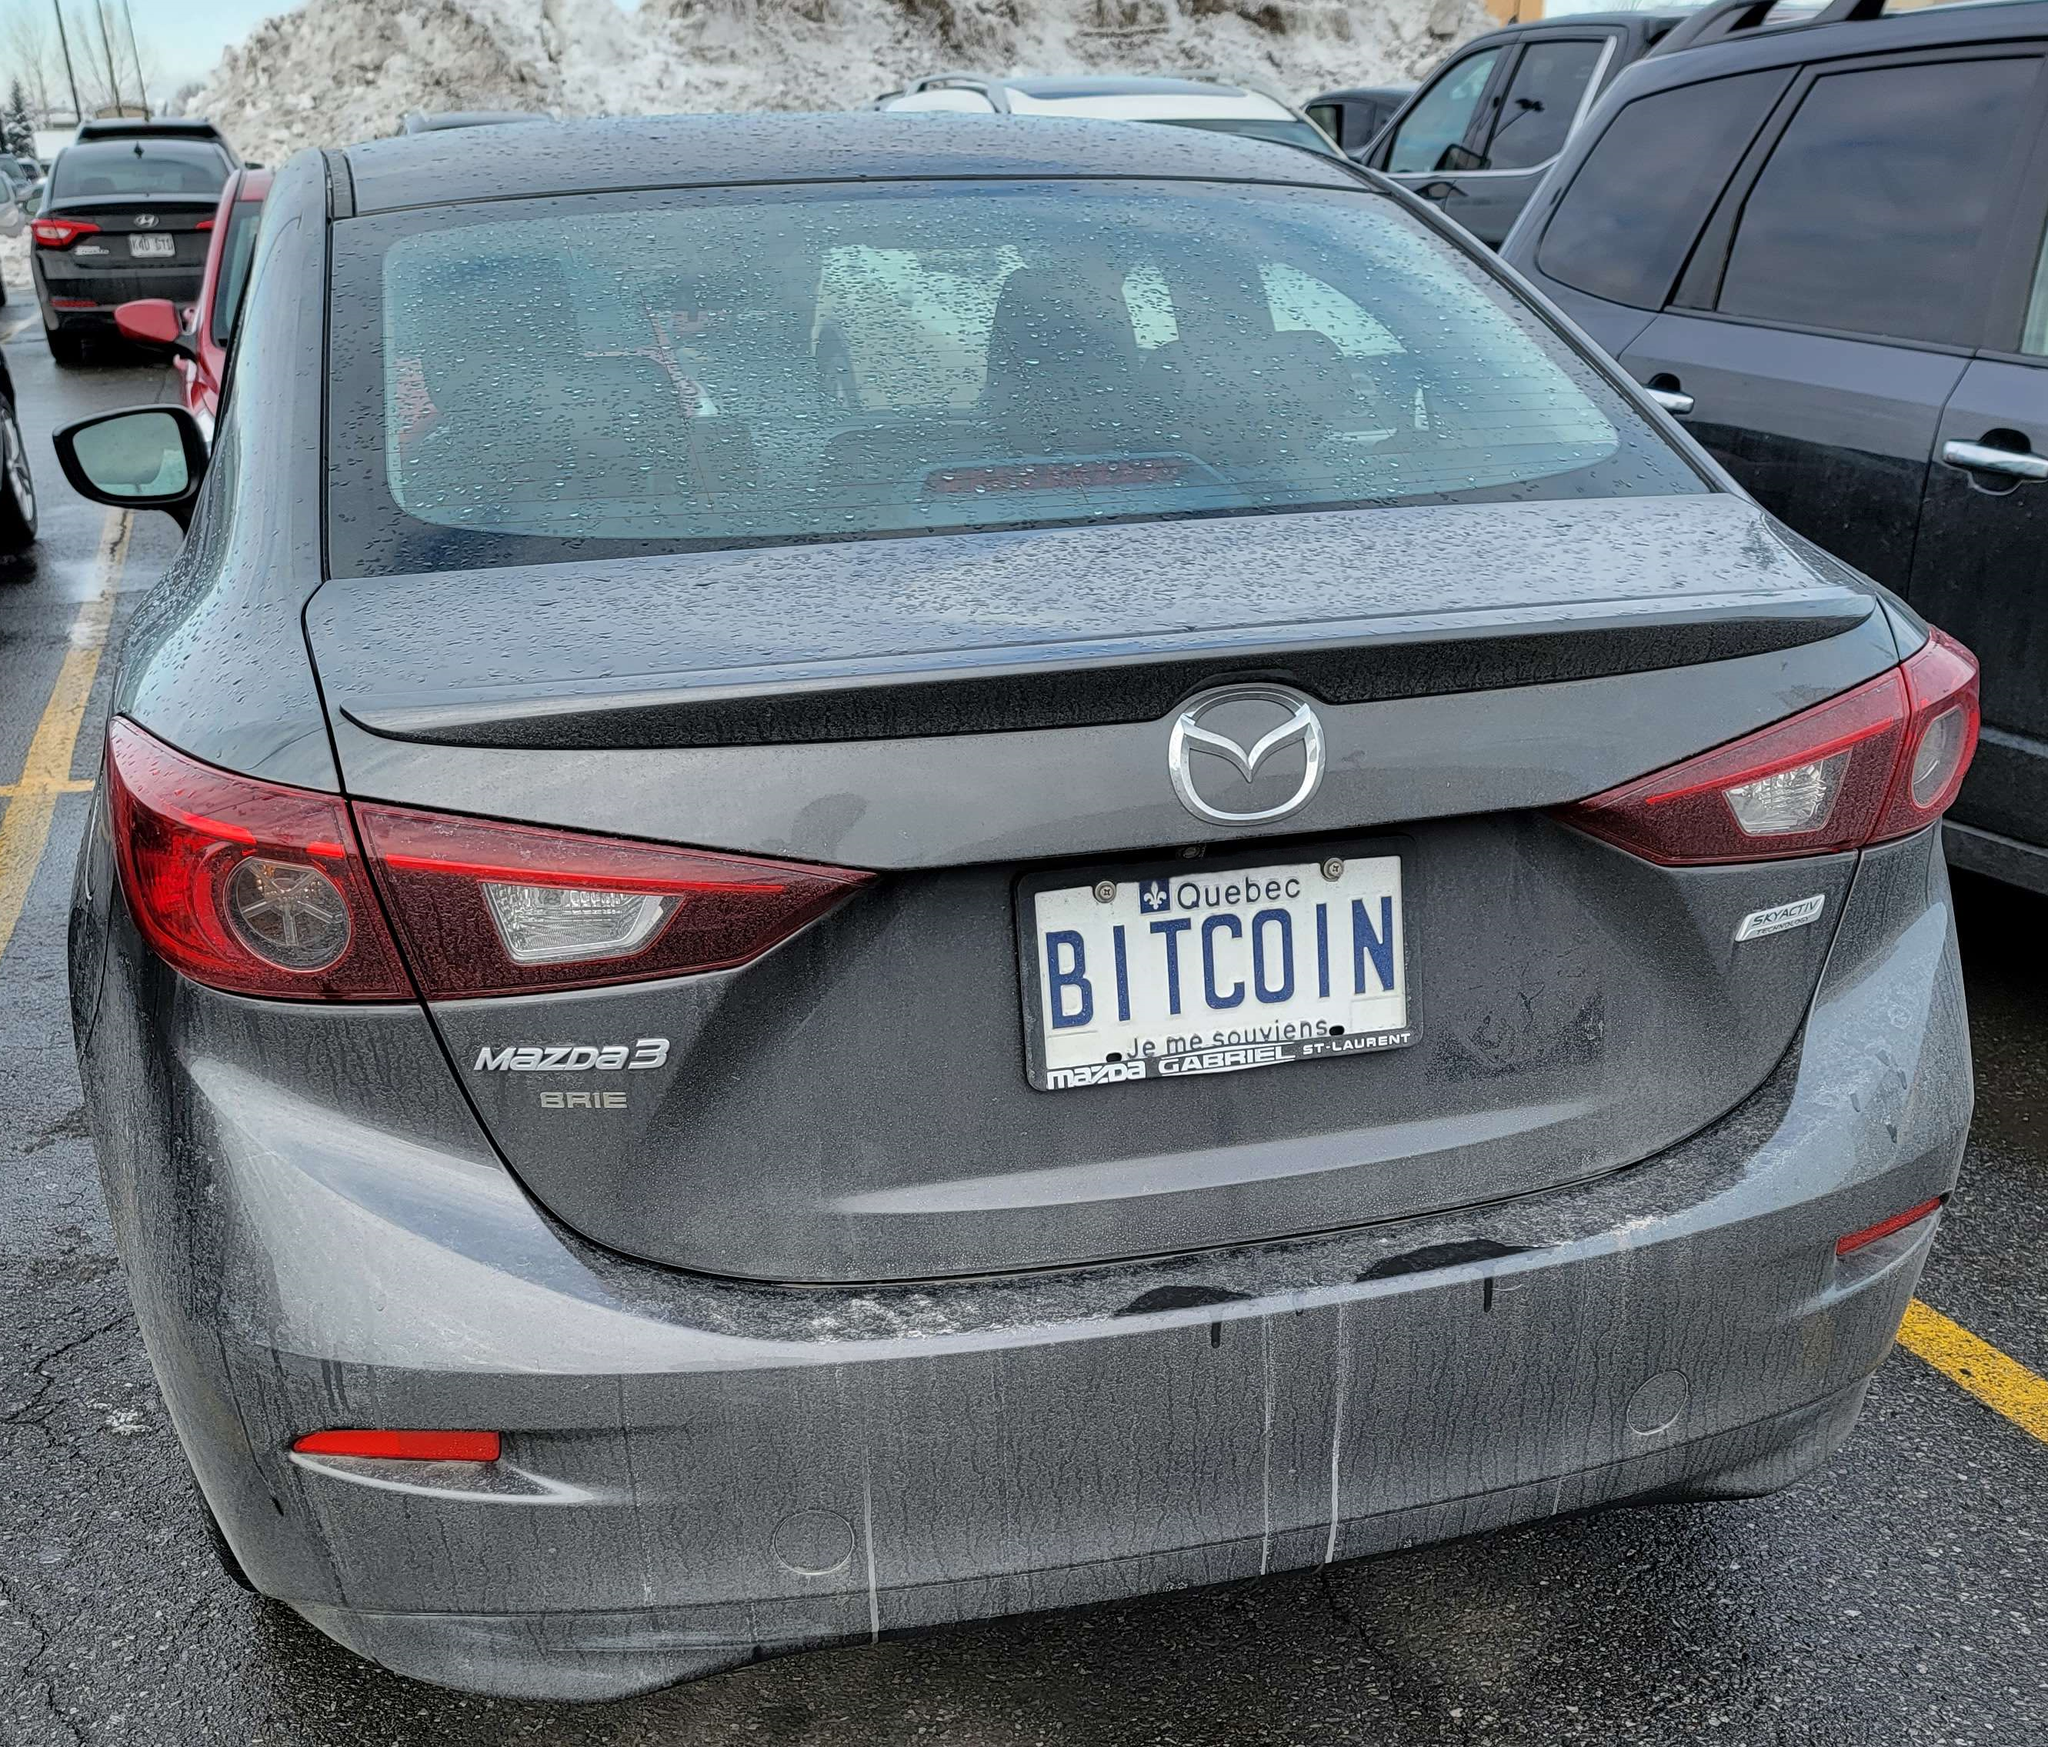where is this license plate issued at?  The license plate on the car says "Quebec Bitcoin", indicating this plate was issued in the province of Quebec, Canada. 